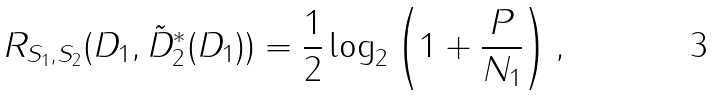Convert formula to latex. <formula><loc_0><loc_0><loc_500><loc_500>R _ { S _ { 1 } , S _ { 2 } } ( D _ { 1 } , \tilde { D } _ { 2 } ^ { \ast } ( D _ { 1 } ) ) = \frac { 1 } { 2 } \log _ { 2 } \left ( 1 + \frac { P } { N _ { 1 } } \right ) ,</formula> 